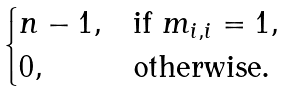<formula> <loc_0><loc_0><loc_500><loc_500>\begin{cases} n - 1 , & \text {if } m _ { i , i } = 1 , \\ 0 , & \text {otherwise.} \end{cases}</formula> 